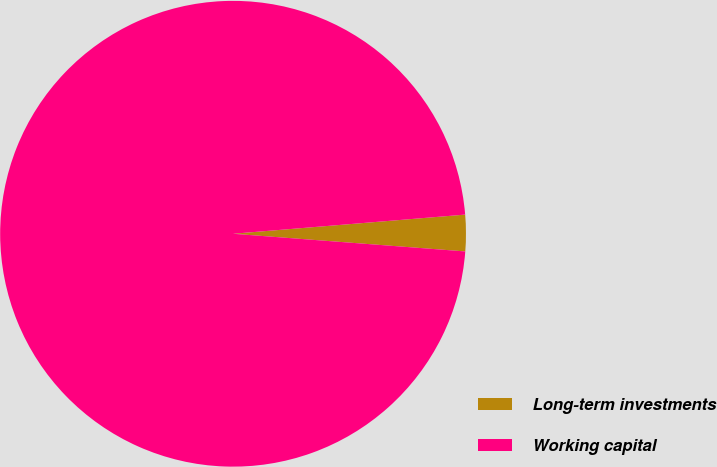Convert chart. <chart><loc_0><loc_0><loc_500><loc_500><pie_chart><fcel>Long-term investments<fcel>Working capital<nl><fcel>2.52%<fcel>97.48%<nl></chart> 